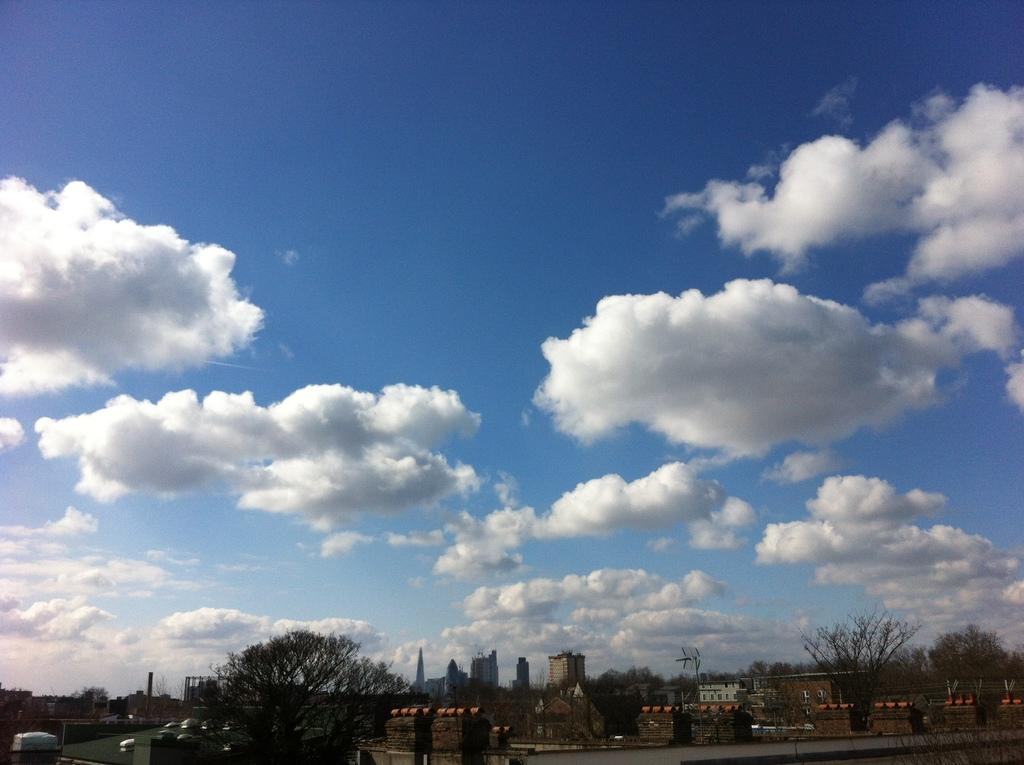What type of natural elements can be seen in the image? There are trees in the image. What type of man-made structures are present in the image? There are buildings in the image. Can you describe any other objects in the image? Yes, there are some objects in the image. What can be seen in the background of the image? The sky is visible in the background of the image. What is the condition of the sky in the image? Clouds are present in the sky. Can you tell me how many rats are playing volleyball in the image? There are no rats or volleyball present in the image. Who is providing help to the people in the image? There is no indication of anyone providing help in the image. 